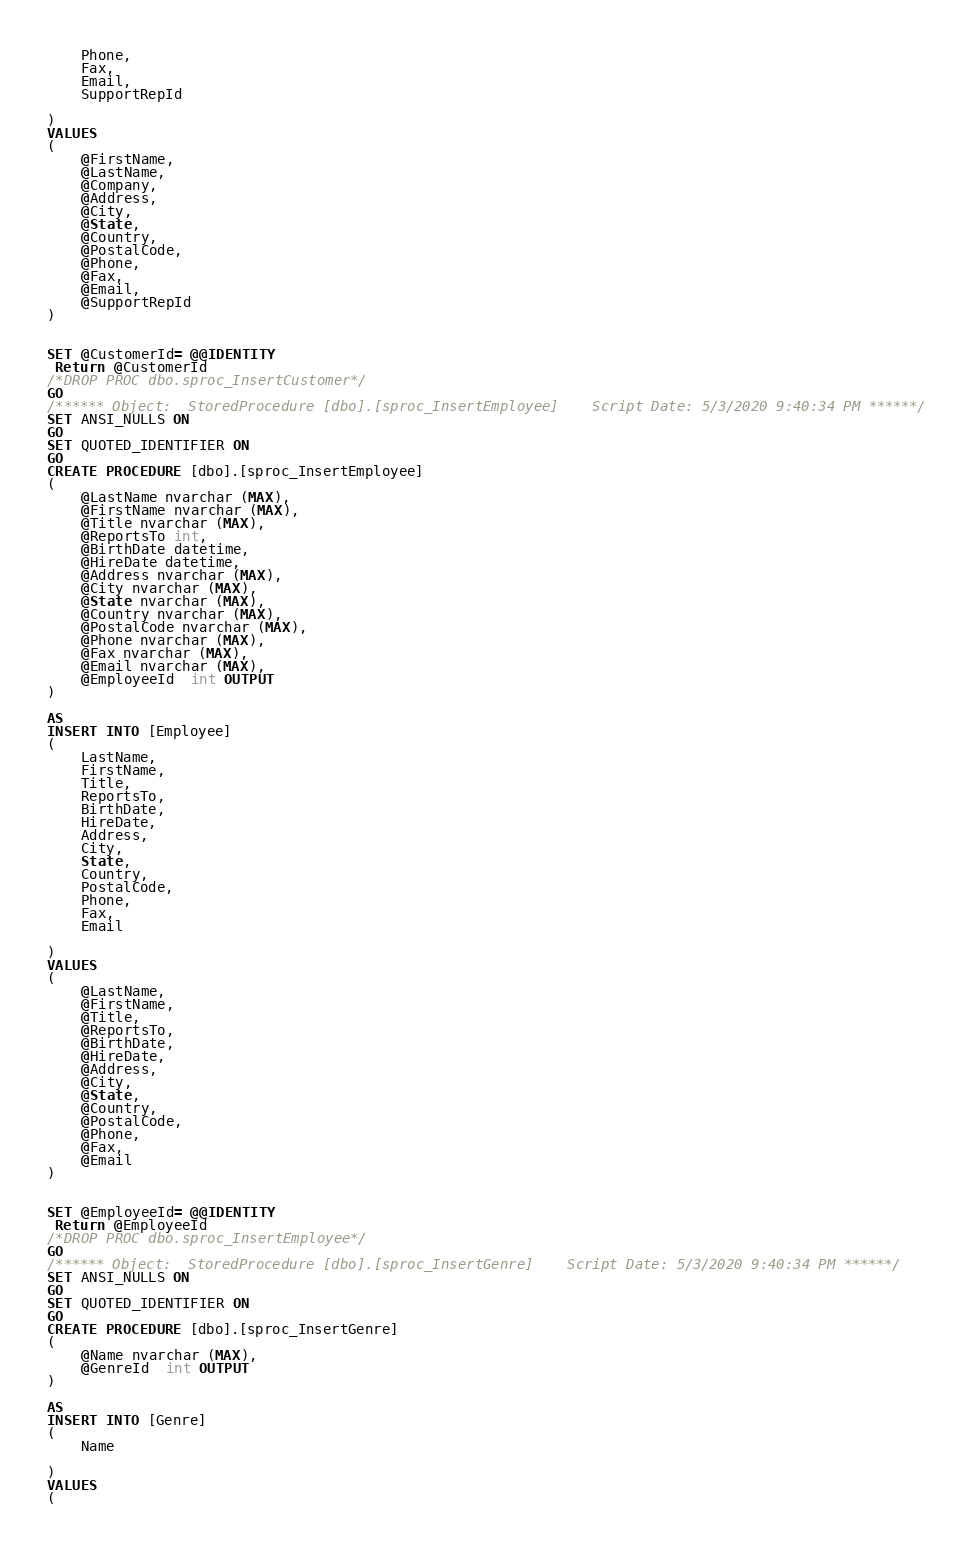Convert code to text. <code><loc_0><loc_0><loc_500><loc_500><_SQL_>	Phone,
	Fax,
	Email,
	SupportRepId

)
VALUES 
(
	@FirstName,
	@LastName,
	@Company,
	@Address,
	@City,
	@State,
	@Country,
	@PostalCode,
	@Phone,
	@Fax,
	@Email,
	@SupportRepId
)


SET @CustomerId= @@IDENTITY
 Return @CustomerId
/*DROP PROC dbo.sproc_InsertCustomer*/
GO
/****** Object:  StoredProcedure [dbo].[sproc_InsertEmployee]    Script Date: 5/3/2020 9:40:34 PM ******/
SET ANSI_NULLS ON
GO
SET QUOTED_IDENTIFIER ON
GO
CREATE PROCEDURE [dbo].[sproc_InsertEmployee]
(
	@LastName nvarchar (MAX),
	@FirstName nvarchar (MAX),
	@Title nvarchar (MAX),
	@ReportsTo int,
	@BirthDate datetime,
	@HireDate datetime,
	@Address nvarchar (MAX),
	@City nvarchar (MAX),
	@State nvarchar (MAX),
	@Country nvarchar (MAX),
	@PostalCode nvarchar (MAX),
	@Phone nvarchar (MAX),
	@Fax nvarchar (MAX),
	@Email nvarchar (MAX),
	@EmployeeId  int OUTPUT
)

AS
INSERT INTO [Employee]
( 
	LastName,
	FirstName,
	Title,
	ReportsTo,
	BirthDate,
	HireDate,
	Address,
	City,
	State,
	Country,
	PostalCode,
	Phone,
	Fax,
	Email

)
VALUES 
(
	@LastName,
	@FirstName,
	@Title,
	@ReportsTo,
	@BirthDate,
	@HireDate,
	@Address,
	@City,
	@State,
	@Country,
	@PostalCode,
	@Phone,
	@Fax,
	@Email
)


SET @EmployeeId= @@IDENTITY
 Return @EmployeeId
/*DROP PROC dbo.sproc_InsertEmployee*/
GO
/****** Object:  StoredProcedure [dbo].[sproc_InsertGenre]    Script Date: 5/3/2020 9:40:34 PM ******/
SET ANSI_NULLS ON
GO
SET QUOTED_IDENTIFIER ON
GO
CREATE PROCEDURE [dbo].[sproc_InsertGenre]
(
	@Name nvarchar (MAX),
	@GenreId  int OUTPUT
)

AS
INSERT INTO [Genre]
( 
	Name

)
VALUES 
(</code> 